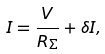Convert formula to latex. <formula><loc_0><loc_0><loc_500><loc_500>I = \frac { V } { R _ { \Sigma } } + \delta I ,</formula> 